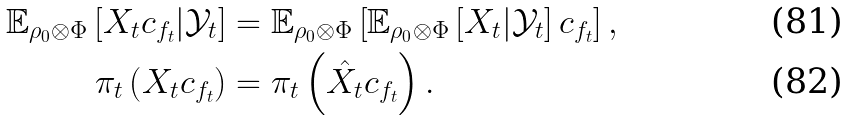Convert formula to latex. <formula><loc_0><loc_0><loc_500><loc_500>\mathbb { E } _ { \rho _ { 0 } \otimes \Phi } \left [ X _ { t } c _ { f _ { t } } | \mathcal { Y } _ { t } \right ] & = \mathbb { E } _ { \rho _ { 0 } \otimes \Phi } \left [ \mathbb { E } _ { \rho _ { 0 } \otimes \Phi } \left [ X _ { t } | \mathcal { Y } _ { t } \right ] c _ { f _ { t } } \right ] , \\ \pi _ { t } \left ( X _ { t } c _ { f _ { t } } \right ) & = \pi _ { t } \left ( \hat { X } _ { t } c _ { f _ { t } } \right ) .</formula> 